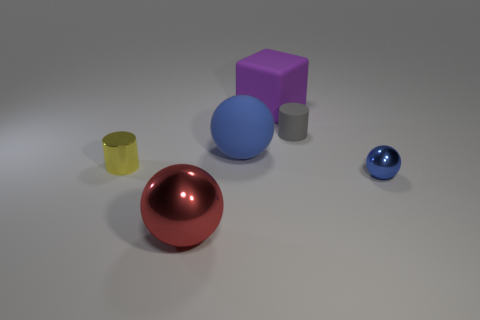Add 4 blocks. How many objects exist? 10 Subtract all cylinders. How many objects are left? 4 Add 4 blue matte cylinders. How many blue matte cylinders exist? 4 Subtract 0 brown blocks. How many objects are left? 6 Subtract all big purple rubber cubes. Subtract all rubber balls. How many objects are left? 4 Add 2 large matte blocks. How many large matte blocks are left? 3 